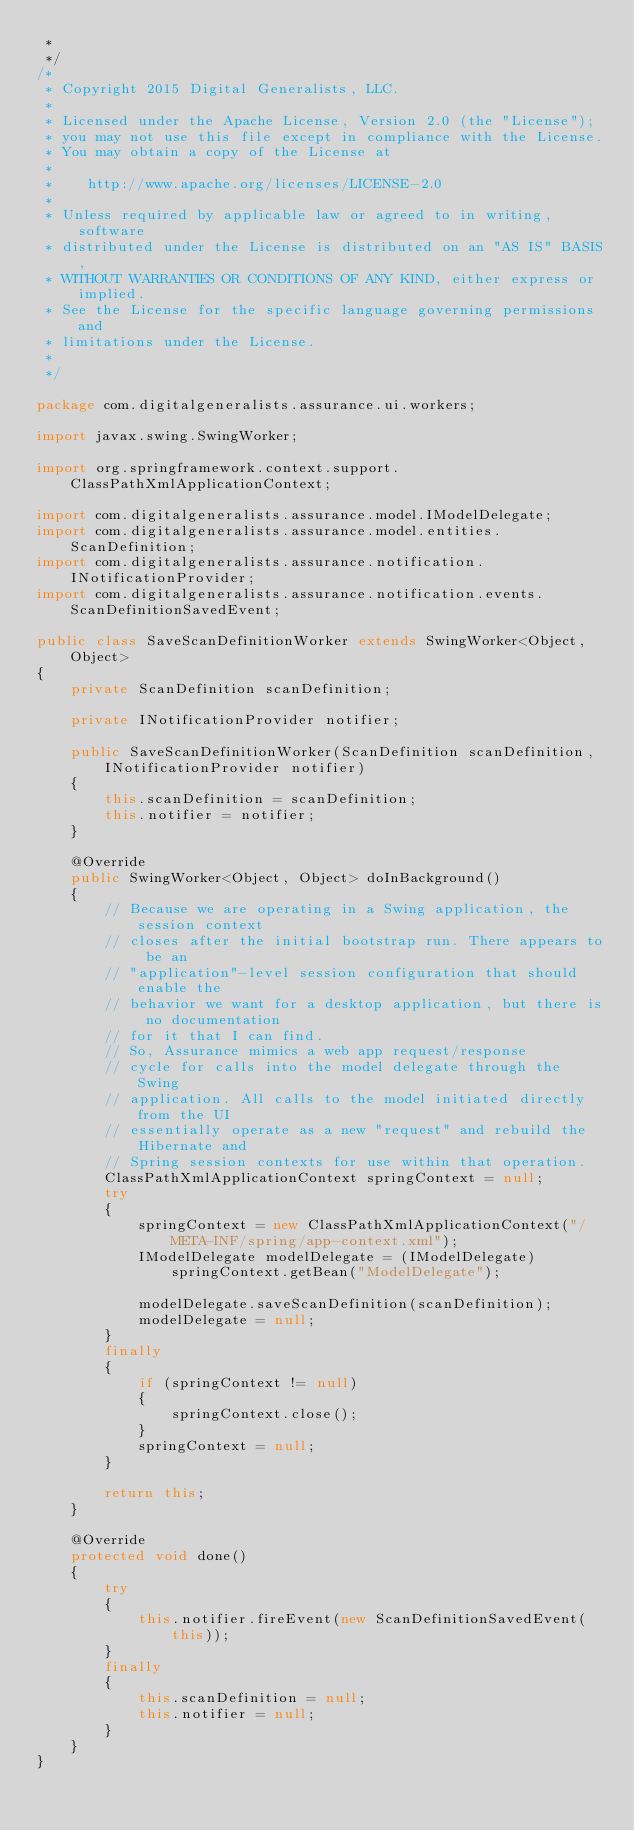<code> <loc_0><loc_0><loc_500><loc_500><_Java_> * 
 */
/*
 * Copyright 2015 Digital Generalists, LLC.
 *
 * Licensed under the Apache License, Version 2.0 (the "License");
 * you may not use this file except in compliance with the License.
 * You may obtain a copy of the License at
 *
 *    http://www.apache.org/licenses/LICENSE-2.0
 *
 * Unless required by applicable law or agreed to in writing, software
 * distributed under the License is distributed on an "AS IS" BASIS,
 * WITHOUT WARRANTIES OR CONDITIONS OF ANY KIND, either express or implied.
 * See the License for the specific language governing permissions and
 * limitations under the License.
 * 
 */

package com.digitalgeneralists.assurance.ui.workers;

import javax.swing.SwingWorker;

import org.springframework.context.support.ClassPathXmlApplicationContext;

import com.digitalgeneralists.assurance.model.IModelDelegate;
import com.digitalgeneralists.assurance.model.entities.ScanDefinition;
import com.digitalgeneralists.assurance.notification.INotificationProvider;
import com.digitalgeneralists.assurance.notification.events.ScanDefinitionSavedEvent;

public class SaveScanDefinitionWorker extends SwingWorker<Object, Object>
{
	private ScanDefinition scanDefinition;

	private INotificationProvider notifier;

	public SaveScanDefinitionWorker(ScanDefinition scanDefinition, INotificationProvider notifier)
	{
		this.scanDefinition = scanDefinition;
		this.notifier = notifier;
	}

	@Override
	public SwingWorker<Object, Object> doInBackground()
	{
		// Because we are operating in a Swing application, the session context
		// closes after the initial bootstrap run. There appears to be an
		// "application"-level session configuration that should enable the
		// behavior we want for a desktop application, but there is no documentation
		// for it that I can find. 
		// So, Assurance mimics a web app request/response
		// cycle for calls into the model delegate through the Swing
		// application. All calls to the model initiated directly from the UI
		// essentially operate as a new "request" and rebuild the Hibernate and
		// Spring session contexts for use within that operation.
		ClassPathXmlApplicationContext springContext = null;
		try
		{
			springContext = new ClassPathXmlApplicationContext("/META-INF/spring/app-context.xml");
			IModelDelegate modelDelegate = (IModelDelegate) springContext.getBean("ModelDelegate");

			modelDelegate.saveScanDefinition(scanDefinition);
			modelDelegate = null;
		}
		finally
		{
			if (springContext != null)
			{
				springContext.close();
			}
			springContext = null;
		}

		return this;
	}

	@Override
	protected void done()
	{
		try
		{
			this.notifier.fireEvent(new ScanDefinitionSavedEvent(this));
		}
		finally
		{
			this.scanDefinition = null;
			this.notifier = null;
		}
	}
}
</code> 